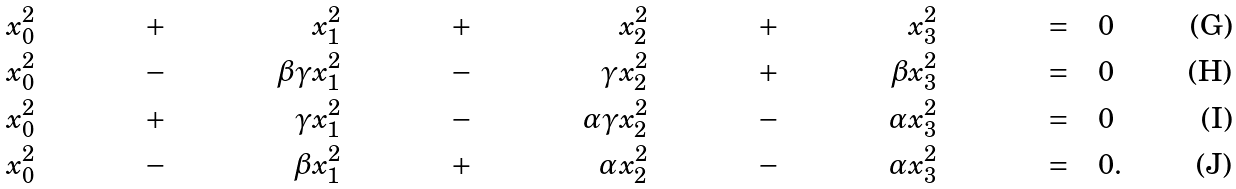Convert formula to latex. <formula><loc_0><loc_0><loc_500><loc_500>& x _ { 0 } ^ { 2 } & & + & & x _ { 1 } ^ { 2 } & & + & & x _ { 2 } ^ { 2 } & & + & & x _ { 3 } ^ { 2 } & = & \quad 0 \\ & x _ { 0 } ^ { 2 } & & - & \beta \gamma & x _ { 1 } ^ { 2 } & & - & \gamma & x _ { 2 } ^ { 2 } & & + & \beta & x _ { 3 } ^ { 2 } & = & \quad 0 \\ & x _ { 0 } ^ { 2 } & & + & \gamma & x _ { 1 } ^ { 2 } & & - & \alpha \gamma & x _ { 2 } ^ { 2 } & & - & \alpha & x _ { 3 } ^ { 2 } & = & \quad 0 \\ & x _ { 0 } ^ { 2 } & & - & \beta & x _ { 1 } ^ { 2 } & & + & \alpha & x _ { 2 } ^ { 2 } & & - & \alpha & x _ { 3 } ^ { 2 } & = & \quad 0 .</formula> 